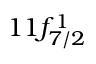Convert formula to latex. <formula><loc_0><loc_0><loc_500><loc_500>1 1 f _ { 7 / 2 } ^ { 1 }</formula> 